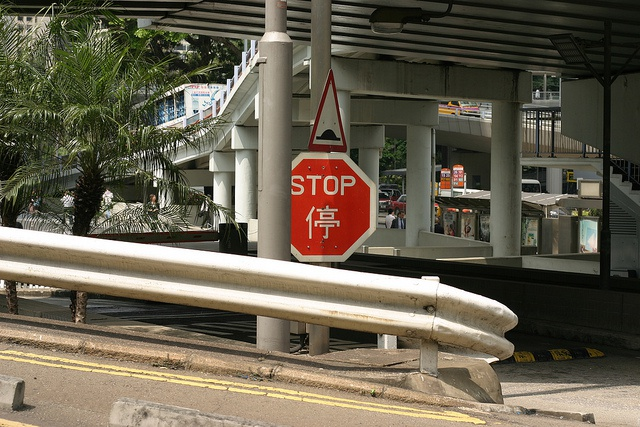Describe the objects in this image and their specific colors. I can see stop sign in black, brown, darkgray, and tan tones, bus in black, lightgray, gray, and darkgray tones, people in black, gray, darkgray, and lightgray tones, people in black, gray, darkgreen, and lightgray tones, and car in black, gray, maroon, and brown tones in this image. 